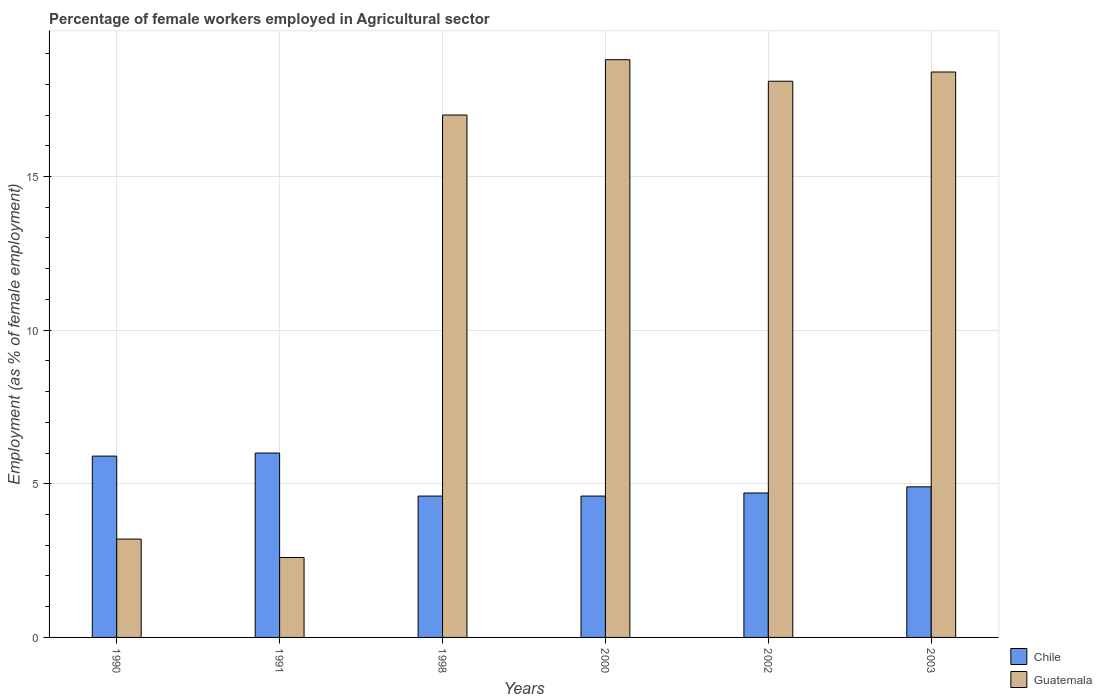How many different coloured bars are there?
Make the answer very short. 2. Are the number of bars per tick equal to the number of legend labels?
Give a very brief answer. Yes. How many bars are there on the 5th tick from the left?
Keep it short and to the point. 2. How many bars are there on the 4th tick from the right?
Offer a terse response. 2. What is the label of the 3rd group of bars from the left?
Offer a very short reply. 1998. What is the percentage of females employed in Agricultural sector in Chile in 1998?
Your answer should be very brief. 4.6. Across all years, what is the maximum percentage of females employed in Agricultural sector in Guatemala?
Offer a very short reply. 18.8. Across all years, what is the minimum percentage of females employed in Agricultural sector in Guatemala?
Your answer should be very brief. 2.6. In which year was the percentage of females employed in Agricultural sector in Guatemala maximum?
Give a very brief answer. 2000. What is the total percentage of females employed in Agricultural sector in Guatemala in the graph?
Provide a succinct answer. 78.1. What is the difference between the percentage of females employed in Agricultural sector in Guatemala in 1991 and that in 2000?
Provide a short and direct response. -16.2. What is the difference between the percentage of females employed in Agricultural sector in Chile in 2003 and the percentage of females employed in Agricultural sector in Guatemala in 1990?
Offer a terse response. 1.7. What is the average percentage of females employed in Agricultural sector in Guatemala per year?
Your answer should be compact. 13.02. In the year 2000, what is the difference between the percentage of females employed in Agricultural sector in Guatemala and percentage of females employed in Agricultural sector in Chile?
Provide a succinct answer. 14.2. In how many years, is the percentage of females employed in Agricultural sector in Guatemala greater than 2 %?
Make the answer very short. 6. What is the ratio of the percentage of females employed in Agricultural sector in Guatemala in 1998 to that in 2002?
Your answer should be compact. 0.94. Is the percentage of females employed in Agricultural sector in Guatemala in 2000 less than that in 2003?
Provide a short and direct response. No. What is the difference between the highest and the second highest percentage of females employed in Agricultural sector in Guatemala?
Make the answer very short. 0.4. What is the difference between the highest and the lowest percentage of females employed in Agricultural sector in Guatemala?
Your answer should be very brief. 16.2. Is the sum of the percentage of females employed in Agricultural sector in Chile in 1991 and 1998 greater than the maximum percentage of females employed in Agricultural sector in Guatemala across all years?
Make the answer very short. No. What does the 2nd bar from the left in 2000 represents?
Provide a succinct answer. Guatemala. How many bars are there?
Offer a very short reply. 12. Are all the bars in the graph horizontal?
Keep it short and to the point. No. What is the difference between two consecutive major ticks on the Y-axis?
Provide a short and direct response. 5. Does the graph contain grids?
Offer a terse response. Yes. Where does the legend appear in the graph?
Your answer should be very brief. Bottom right. How are the legend labels stacked?
Ensure brevity in your answer.  Vertical. What is the title of the graph?
Offer a terse response. Percentage of female workers employed in Agricultural sector. Does "Iraq" appear as one of the legend labels in the graph?
Your answer should be very brief. No. What is the label or title of the X-axis?
Your response must be concise. Years. What is the label or title of the Y-axis?
Your response must be concise. Employment (as % of female employment). What is the Employment (as % of female employment) of Chile in 1990?
Provide a succinct answer. 5.9. What is the Employment (as % of female employment) in Guatemala in 1990?
Make the answer very short. 3.2. What is the Employment (as % of female employment) of Chile in 1991?
Your answer should be very brief. 6. What is the Employment (as % of female employment) of Guatemala in 1991?
Ensure brevity in your answer.  2.6. What is the Employment (as % of female employment) of Chile in 1998?
Offer a terse response. 4.6. What is the Employment (as % of female employment) of Chile in 2000?
Provide a short and direct response. 4.6. What is the Employment (as % of female employment) of Guatemala in 2000?
Your answer should be compact. 18.8. What is the Employment (as % of female employment) of Chile in 2002?
Your answer should be compact. 4.7. What is the Employment (as % of female employment) in Guatemala in 2002?
Your response must be concise. 18.1. What is the Employment (as % of female employment) of Chile in 2003?
Keep it short and to the point. 4.9. What is the Employment (as % of female employment) of Guatemala in 2003?
Provide a short and direct response. 18.4. Across all years, what is the maximum Employment (as % of female employment) of Chile?
Keep it short and to the point. 6. Across all years, what is the maximum Employment (as % of female employment) in Guatemala?
Keep it short and to the point. 18.8. Across all years, what is the minimum Employment (as % of female employment) of Chile?
Your answer should be compact. 4.6. Across all years, what is the minimum Employment (as % of female employment) in Guatemala?
Make the answer very short. 2.6. What is the total Employment (as % of female employment) of Chile in the graph?
Provide a succinct answer. 30.7. What is the total Employment (as % of female employment) of Guatemala in the graph?
Keep it short and to the point. 78.1. What is the difference between the Employment (as % of female employment) of Guatemala in 1990 and that in 1991?
Give a very brief answer. 0.6. What is the difference between the Employment (as % of female employment) in Chile in 1990 and that in 2000?
Offer a very short reply. 1.3. What is the difference between the Employment (as % of female employment) in Guatemala in 1990 and that in 2000?
Provide a succinct answer. -15.6. What is the difference between the Employment (as % of female employment) in Chile in 1990 and that in 2002?
Ensure brevity in your answer.  1.2. What is the difference between the Employment (as % of female employment) in Guatemala in 1990 and that in 2002?
Ensure brevity in your answer.  -14.9. What is the difference between the Employment (as % of female employment) in Chile in 1990 and that in 2003?
Your answer should be compact. 1. What is the difference between the Employment (as % of female employment) in Guatemala in 1990 and that in 2003?
Make the answer very short. -15.2. What is the difference between the Employment (as % of female employment) in Chile in 1991 and that in 1998?
Ensure brevity in your answer.  1.4. What is the difference between the Employment (as % of female employment) in Guatemala in 1991 and that in 1998?
Make the answer very short. -14.4. What is the difference between the Employment (as % of female employment) of Chile in 1991 and that in 2000?
Give a very brief answer. 1.4. What is the difference between the Employment (as % of female employment) in Guatemala in 1991 and that in 2000?
Ensure brevity in your answer.  -16.2. What is the difference between the Employment (as % of female employment) in Chile in 1991 and that in 2002?
Offer a very short reply. 1.3. What is the difference between the Employment (as % of female employment) in Guatemala in 1991 and that in 2002?
Your response must be concise. -15.5. What is the difference between the Employment (as % of female employment) in Guatemala in 1991 and that in 2003?
Your answer should be compact. -15.8. What is the difference between the Employment (as % of female employment) of Chile in 1998 and that in 2000?
Provide a short and direct response. 0. What is the difference between the Employment (as % of female employment) of Guatemala in 1998 and that in 2000?
Offer a terse response. -1.8. What is the difference between the Employment (as % of female employment) of Guatemala in 1998 and that in 2002?
Your response must be concise. -1.1. What is the difference between the Employment (as % of female employment) in Guatemala in 1998 and that in 2003?
Ensure brevity in your answer.  -1.4. What is the difference between the Employment (as % of female employment) of Chile in 2000 and that in 2003?
Provide a succinct answer. -0.3. What is the difference between the Employment (as % of female employment) of Guatemala in 2002 and that in 2003?
Your answer should be compact. -0.3. What is the difference between the Employment (as % of female employment) in Chile in 1990 and the Employment (as % of female employment) in Guatemala in 1991?
Your answer should be very brief. 3.3. What is the difference between the Employment (as % of female employment) in Chile in 1990 and the Employment (as % of female employment) in Guatemala in 2002?
Ensure brevity in your answer.  -12.2. What is the difference between the Employment (as % of female employment) of Chile in 1990 and the Employment (as % of female employment) of Guatemala in 2003?
Provide a succinct answer. -12.5. What is the difference between the Employment (as % of female employment) of Chile in 1991 and the Employment (as % of female employment) of Guatemala in 1998?
Make the answer very short. -11. What is the difference between the Employment (as % of female employment) in Chile in 1991 and the Employment (as % of female employment) in Guatemala in 2000?
Make the answer very short. -12.8. What is the difference between the Employment (as % of female employment) of Chile in 1991 and the Employment (as % of female employment) of Guatemala in 2002?
Your answer should be compact. -12.1. What is the difference between the Employment (as % of female employment) in Chile in 2000 and the Employment (as % of female employment) in Guatemala in 2003?
Provide a short and direct response. -13.8. What is the difference between the Employment (as % of female employment) in Chile in 2002 and the Employment (as % of female employment) in Guatemala in 2003?
Your response must be concise. -13.7. What is the average Employment (as % of female employment) in Chile per year?
Ensure brevity in your answer.  5.12. What is the average Employment (as % of female employment) in Guatemala per year?
Keep it short and to the point. 13.02. In the year 2000, what is the difference between the Employment (as % of female employment) in Chile and Employment (as % of female employment) in Guatemala?
Provide a short and direct response. -14.2. In the year 2003, what is the difference between the Employment (as % of female employment) in Chile and Employment (as % of female employment) in Guatemala?
Provide a succinct answer. -13.5. What is the ratio of the Employment (as % of female employment) of Chile in 1990 to that in 1991?
Your answer should be compact. 0.98. What is the ratio of the Employment (as % of female employment) in Guatemala in 1990 to that in 1991?
Make the answer very short. 1.23. What is the ratio of the Employment (as % of female employment) in Chile in 1990 to that in 1998?
Your answer should be compact. 1.28. What is the ratio of the Employment (as % of female employment) in Guatemala in 1990 to that in 1998?
Your answer should be compact. 0.19. What is the ratio of the Employment (as % of female employment) in Chile in 1990 to that in 2000?
Make the answer very short. 1.28. What is the ratio of the Employment (as % of female employment) of Guatemala in 1990 to that in 2000?
Ensure brevity in your answer.  0.17. What is the ratio of the Employment (as % of female employment) in Chile in 1990 to that in 2002?
Keep it short and to the point. 1.26. What is the ratio of the Employment (as % of female employment) in Guatemala in 1990 to that in 2002?
Provide a succinct answer. 0.18. What is the ratio of the Employment (as % of female employment) in Chile in 1990 to that in 2003?
Offer a very short reply. 1.2. What is the ratio of the Employment (as % of female employment) of Guatemala in 1990 to that in 2003?
Offer a very short reply. 0.17. What is the ratio of the Employment (as % of female employment) of Chile in 1991 to that in 1998?
Ensure brevity in your answer.  1.3. What is the ratio of the Employment (as % of female employment) in Guatemala in 1991 to that in 1998?
Ensure brevity in your answer.  0.15. What is the ratio of the Employment (as % of female employment) of Chile in 1991 to that in 2000?
Provide a succinct answer. 1.3. What is the ratio of the Employment (as % of female employment) in Guatemala in 1991 to that in 2000?
Provide a succinct answer. 0.14. What is the ratio of the Employment (as % of female employment) of Chile in 1991 to that in 2002?
Make the answer very short. 1.28. What is the ratio of the Employment (as % of female employment) in Guatemala in 1991 to that in 2002?
Provide a succinct answer. 0.14. What is the ratio of the Employment (as % of female employment) in Chile in 1991 to that in 2003?
Your answer should be compact. 1.22. What is the ratio of the Employment (as % of female employment) in Guatemala in 1991 to that in 2003?
Provide a short and direct response. 0.14. What is the ratio of the Employment (as % of female employment) of Chile in 1998 to that in 2000?
Provide a succinct answer. 1. What is the ratio of the Employment (as % of female employment) in Guatemala in 1998 to that in 2000?
Ensure brevity in your answer.  0.9. What is the ratio of the Employment (as % of female employment) of Chile in 1998 to that in 2002?
Ensure brevity in your answer.  0.98. What is the ratio of the Employment (as % of female employment) in Guatemala in 1998 to that in 2002?
Your response must be concise. 0.94. What is the ratio of the Employment (as % of female employment) of Chile in 1998 to that in 2003?
Provide a succinct answer. 0.94. What is the ratio of the Employment (as % of female employment) in Guatemala in 1998 to that in 2003?
Give a very brief answer. 0.92. What is the ratio of the Employment (as % of female employment) in Chile in 2000 to that in 2002?
Offer a very short reply. 0.98. What is the ratio of the Employment (as % of female employment) of Guatemala in 2000 to that in 2002?
Provide a short and direct response. 1.04. What is the ratio of the Employment (as % of female employment) of Chile in 2000 to that in 2003?
Provide a short and direct response. 0.94. What is the ratio of the Employment (as % of female employment) in Guatemala in 2000 to that in 2003?
Keep it short and to the point. 1.02. What is the ratio of the Employment (as % of female employment) of Chile in 2002 to that in 2003?
Give a very brief answer. 0.96. What is the ratio of the Employment (as % of female employment) in Guatemala in 2002 to that in 2003?
Provide a succinct answer. 0.98. 